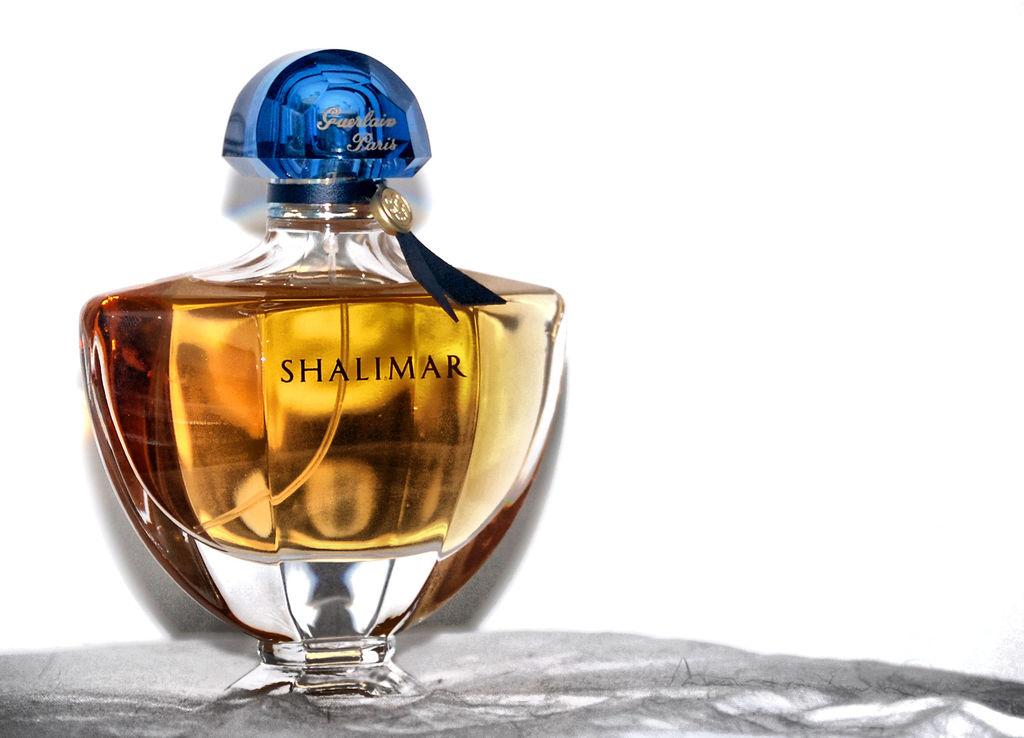<image>
Relay a brief, clear account of the picture shown. a small bottle of perfume that says 'shalimar' on it 